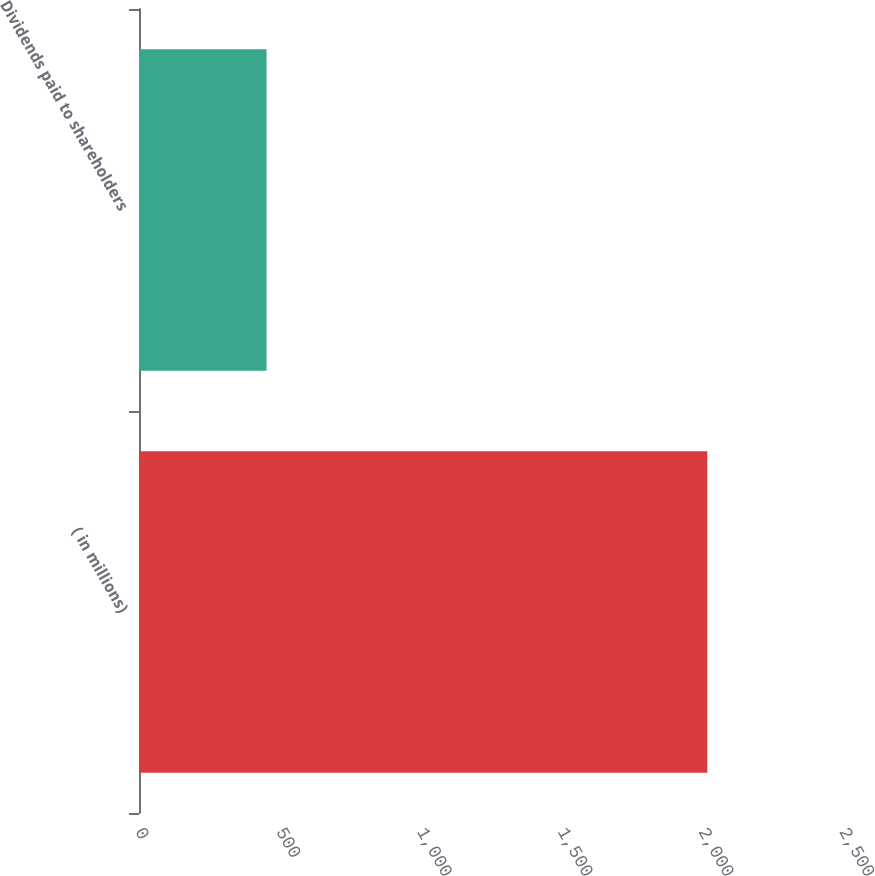Convert chart. <chart><loc_0><loc_0><loc_500><loc_500><bar_chart><fcel>( in millions)<fcel>Dividends paid to shareholders<nl><fcel>2018<fcel>453<nl></chart> 